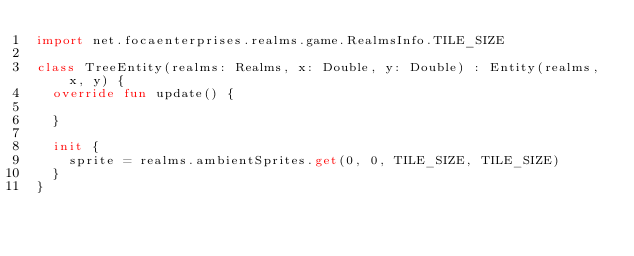Convert code to text. <code><loc_0><loc_0><loc_500><loc_500><_Kotlin_>import net.focaenterprises.realms.game.RealmsInfo.TILE_SIZE

class TreeEntity(realms: Realms, x: Double, y: Double) : Entity(realms, x, y) {
  override fun update() {

  }

  init {
    sprite = realms.ambientSprites.get(0, 0, TILE_SIZE, TILE_SIZE)
  }
}</code> 